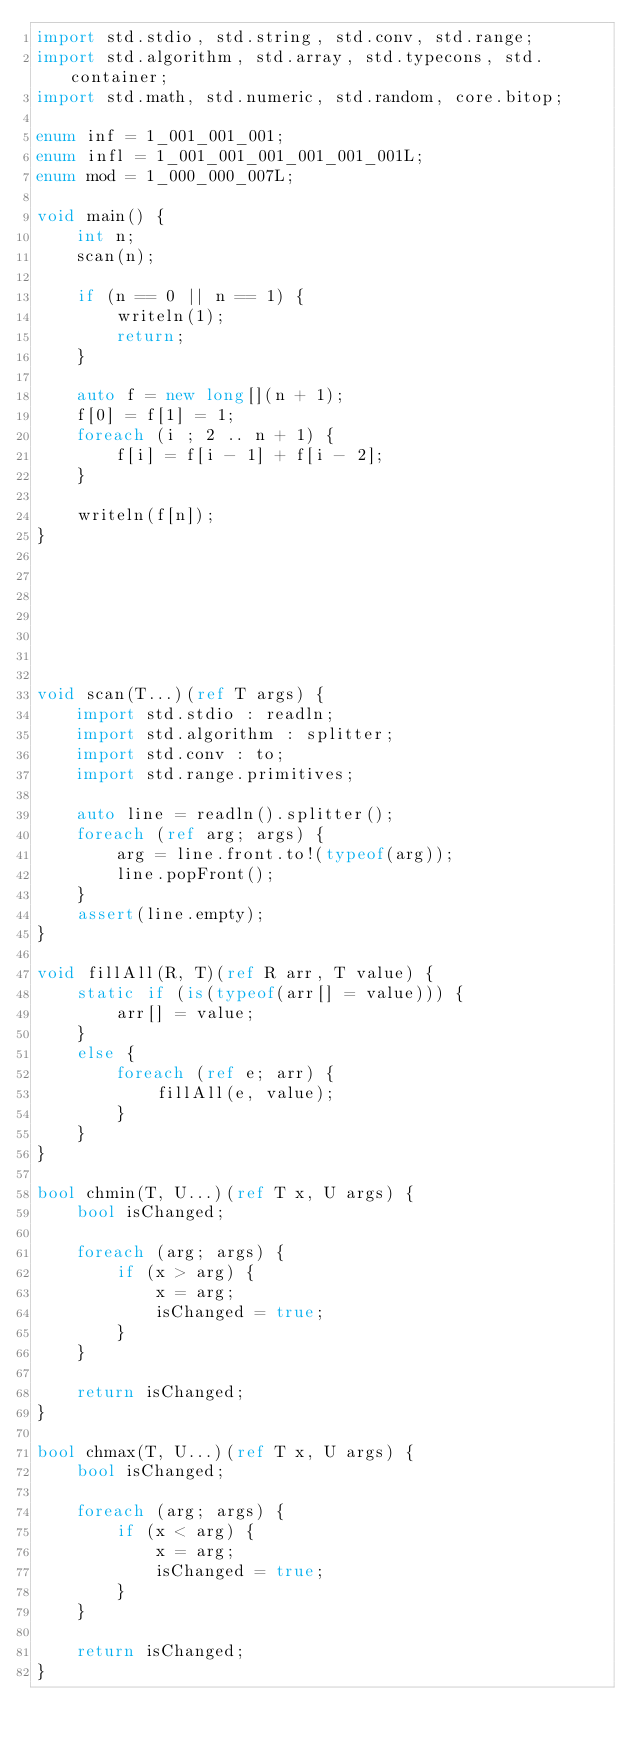Convert code to text. <code><loc_0><loc_0><loc_500><loc_500><_D_>import std.stdio, std.string, std.conv, std.range;
import std.algorithm, std.array, std.typecons, std.container;
import std.math, std.numeric, std.random, core.bitop;

enum inf = 1_001_001_001;
enum infl = 1_001_001_001_001_001_001L;
enum mod = 1_000_000_007L;

void main() {
    int n;
    scan(n);

    if (n == 0 || n == 1) {
        writeln(1);
        return;
    }

    auto f = new long[](n + 1);
    f[0] = f[1] = 1;
    foreach (i ; 2 .. n + 1) {
        f[i] = f[i - 1] + f[i - 2];
    }

    writeln(f[n]);
}







void scan(T...)(ref T args) {
    import std.stdio : readln;
    import std.algorithm : splitter;
    import std.conv : to;
    import std.range.primitives;

    auto line = readln().splitter();
    foreach (ref arg; args) {
        arg = line.front.to!(typeof(arg));
        line.popFront();
    }
    assert(line.empty);
}

void fillAll(R, T)(ref R arr, T value) {
    static if (is(typeof(arr[] = value))) {
        arr[] = value;
    }
    else {
        foreach (ref e; arr) {
            fillAll(e, value);
        }
    }
}

bool chmin(T, U...)(ref T x, U args) {
    bool isChanged;

    foreach (arg; args) {
        if (x > arg) {
            x = arg;
            isChanged = true;
        }
    }

    return isChanged;
}

bool chmax(T, U...)(ref T x, U args) {
    bool isChanged;

    foreach (arg; args) {
        if (x < arg) {
            x = arg;
            isChanged = true;
        }
    }

    return isChanged;
}

</code> 